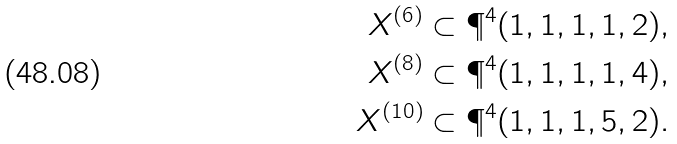Convert formula to latex. <formula><loc_0><loc_0><loc_500><loc_500>X ^ { ( 6 ) } & \subset \P ^ { 4 } ( 1 , 1 , 1 , 1 , 2 ) , \\ X ^ { ( 8 ) } & \subset \P ^ { 4 } ( 1 , 1 , 1 , 1 , 4 ) , \\ X ^ { ( 1 0 ) } & \subset \P ^ { 4 } ( 1 , 1 , 1 , 5 , 2 ) . \\</formula> 